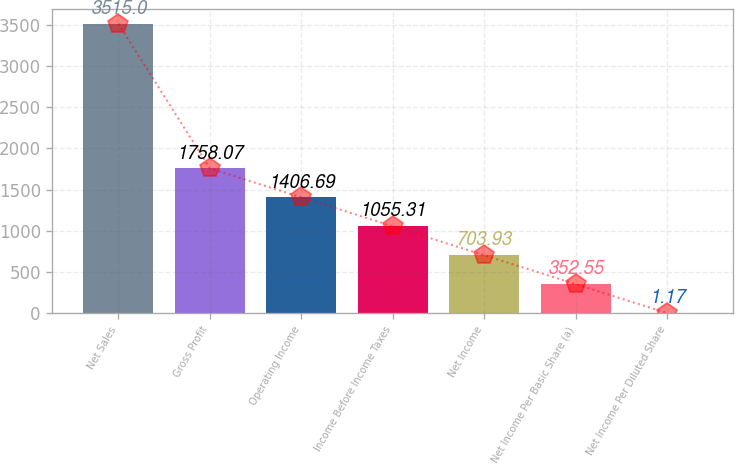Convert chart to OTSL. <chart><loc_0><loc_0><loc_500><loc_500><bar_chart><fcel>Net Sales<fcel>Gross Profit<fcel>Operating Income<fcel>Income Before Income Taxes<fcel>Net Income<fcel>Net Income Per Basic Share (a)<fcel>Net Income Per Diluted Share<nl><fcel>3515<fcel>1758.07<fcel>1406.69<fcel>1055.31<fcel>703.93<fcel>352.55<fcel>1.17<nl></chart> 